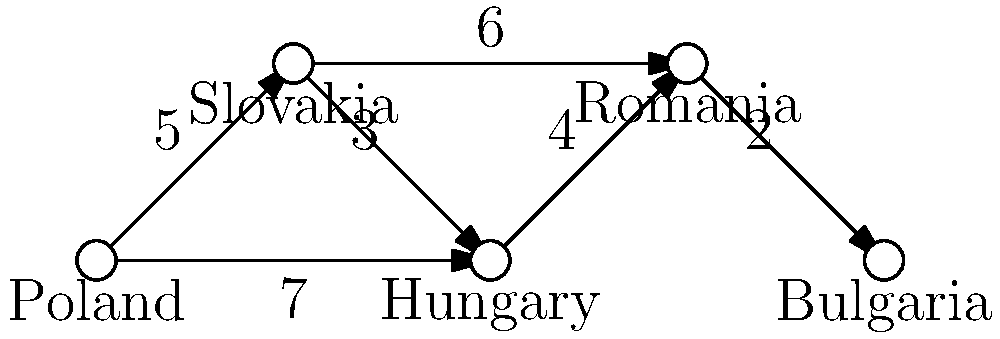During your travels in Eastern Europe, you encountered a network routing problem. A data packet needs to be sent from Poland to Bulgaria through the network shown above. The numbers on the edges represent the time (in milliseconds) it takes for a packet to travel between countries. What is the shortest time (in milliseconds) for the packet to reach Bulgaria from Poland? To find the shortest time for the packet to reach Bulgaria from Poland, we need to consider all possible paths and calculate their total times:

1. Poland → Slovakia → Hungary → Romania → Bulgaria
   Time: 5 + 3 + 4 + 2 = 14 ms

2. Poland → Slovakia → Romania → Bulgaria
   Time: 5 + 6 + 2 = 13 ms

3. Poland → Hungary → Romania → Bulgaria
   Time: 7 + 4 + 2 = 13 ms

The shortest time is 13 ms, which can be achieved through two different routes:
a) Poland → Slovakia → Romania → Bulgaria
b) Poland → Hungary → Romania → Bulgaria

Both of these routes take 13 milliseconds, which is the minimum time required for the packet to reach Bulgaria from Poland.
Answer: 13 ms 